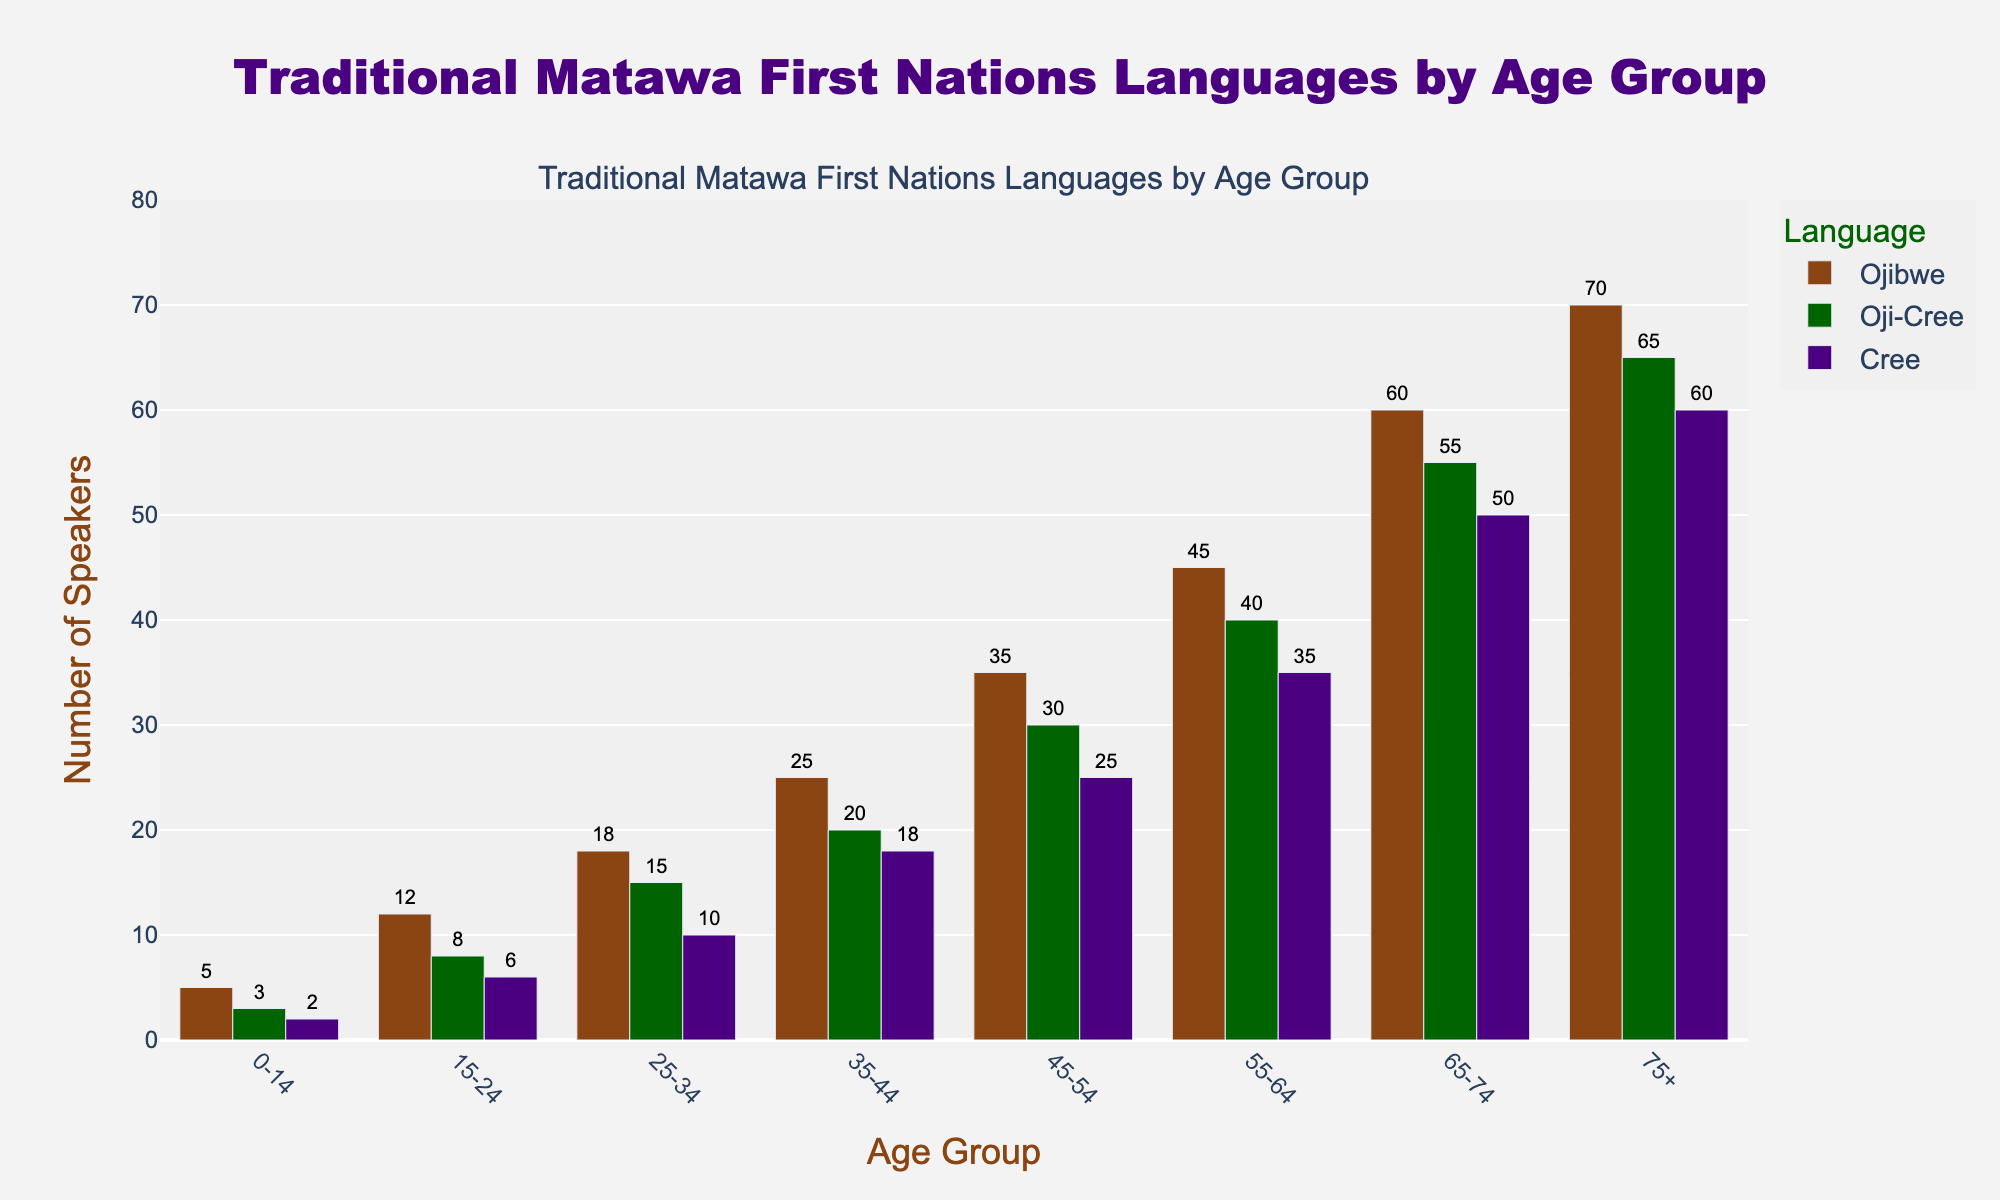What's the total number of Cree speakers across all age groups? Sum the heights of all bars for Cree: 2 + 6 + 10 + 18 + 25 + 35 + 50 + 60 = 206
Answer: 206 Which age group has the highest number of Oji-Cree speakers? Identify the tallest bar for Oji-Cree. The tallest bar is in the 75+ age group with 65 speakers.
Answer: 75+ How many more Ojibwe speakers are there in the 75+ age group compared to the 25-34 age group? Subtract the number of Ojibwe speakers in the 25-34 age group from the number in the 75+ age group: 70 - 18 = 52
Answer: 52 What is the average number of Oji-Cree speakers in the 0-14 and 15-24 age groups? Calculate the average by summing the number of Oji-Cree speakers in the 0-14 and 15-24 age groups and dividing by 2: (3 + 8) / 2 = 5.5
Answer: 5.5 Which language has the most speakers in the 55-64 age group? Compare the height of the bars for each language in the 55-64 age group: Ojibwe: 45, Oji-Cree: 40, Cree: 35. Ojibwe is the highest.
Answer: Ojibwe By how much does the number of Ojibwe speakers increase from the 0-14 age group to the 45-54 age group? Subtract the number of Ojibwe speakers in the 0-14 age group from the number in the 45-54 age group: 35 - 5 = 30
Answer: 30 Which language shows the largest increase in the number of speakers from the 0-14 age group to the 75+ age group? Calculate the difference for each language: 
- Ojibwe: 70 - 5 = 65 
- Oji-Cree: 65 - 3 = 62 
- Cree: 60 - 2 = 58 
Ojibwe has the largest increase.
Answer: Ojibwe What is the combined number of speakers of Oji-Cree and Cree in the 35-44 age group? Sum the number of Oji-Cree and Cree speakers in the 35-44 age group: 20 + 18 = 38
Answer: 38 